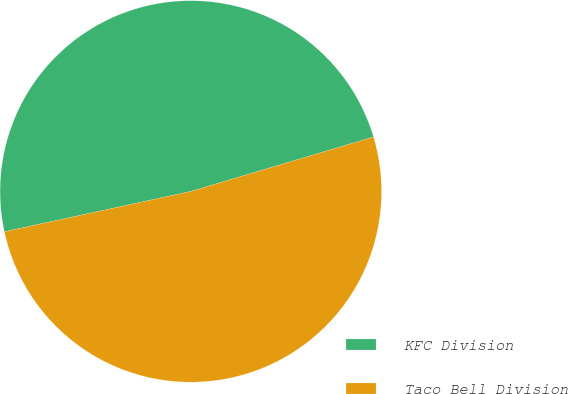<chart> <loc_0><loc_0><loc_500><loc_500><pie_chart><fcel>KFC Division<fcel>Taco Bell Division<nl><fcel>48.78%<fcel>51.22%<nl></chart> 